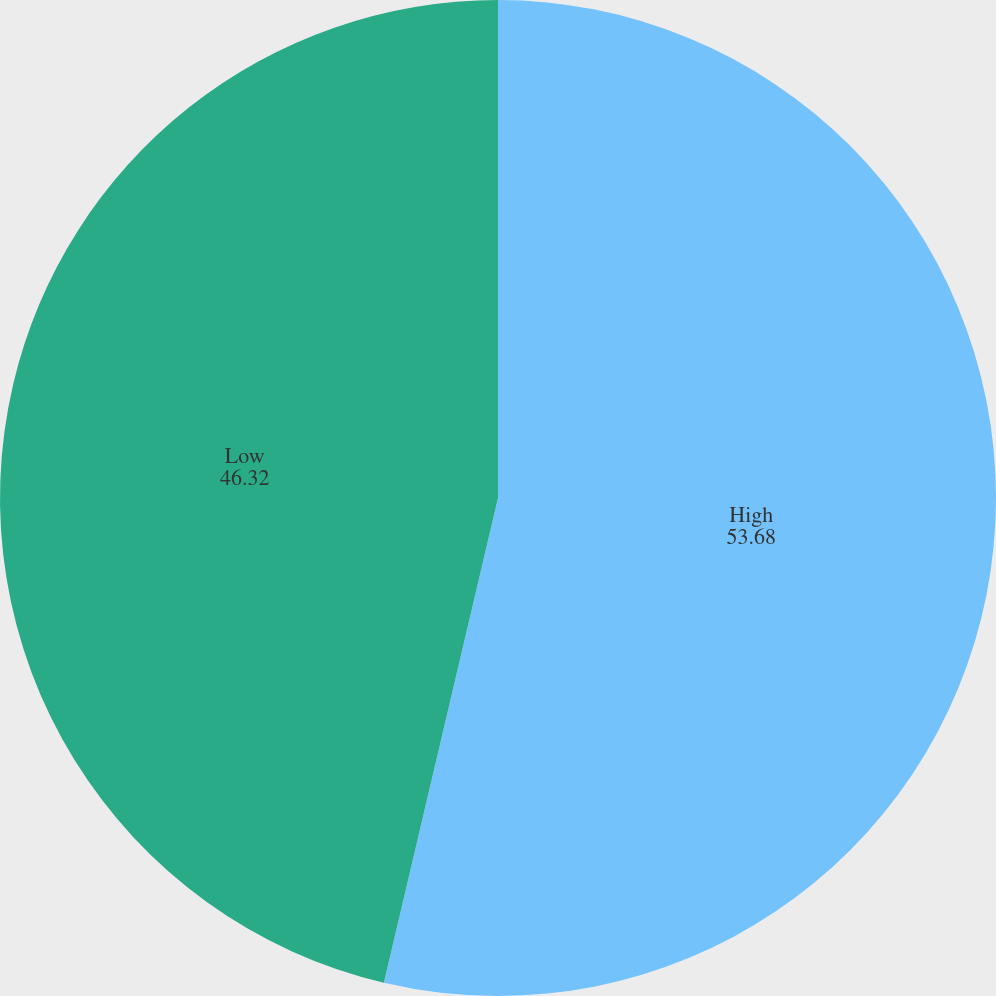Convert chart to OTSL. <chart><loc_0><loc_0><loc_500><loc_500><pie_chart><fcel>High<fcel>Low<nl><fcel>53.68%<fcel>46.32%<nl></chart> 